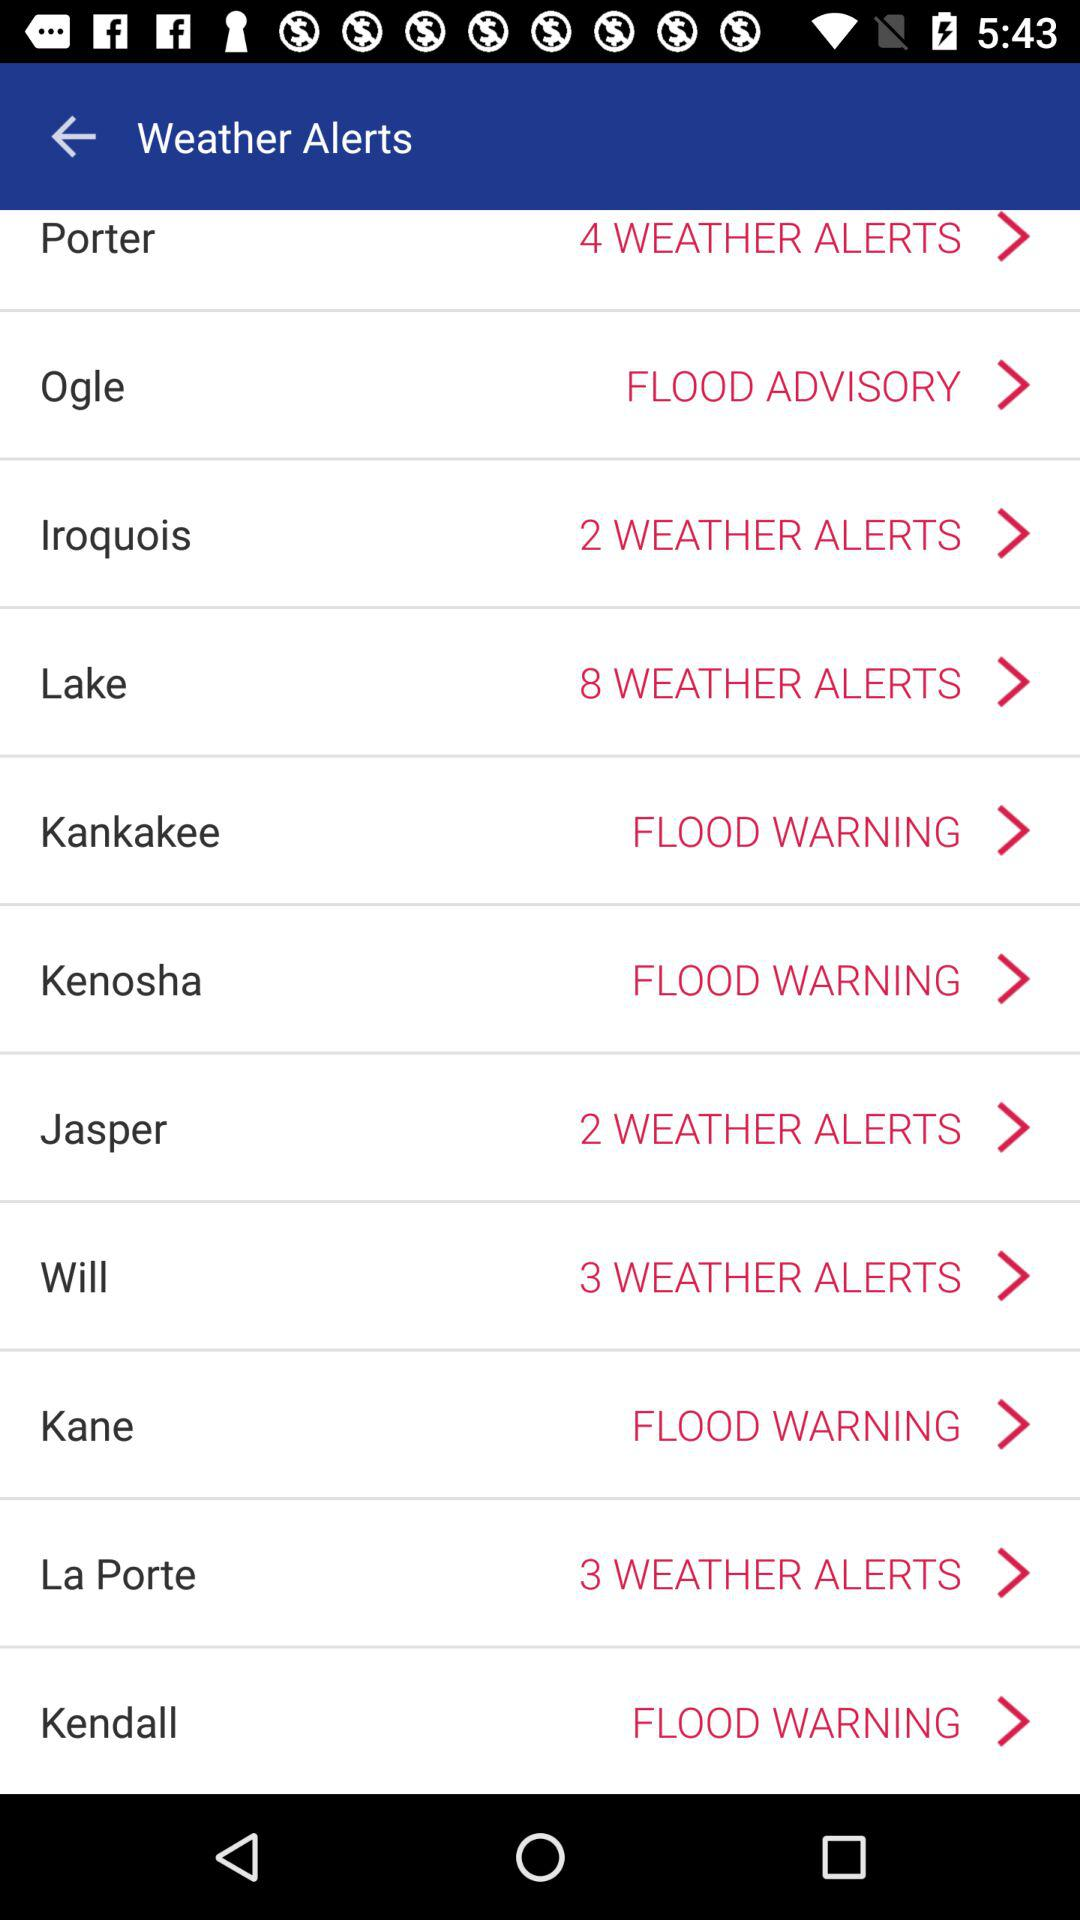What is the weather alert for Kane? The weather alert for Kane is "FLOOD WARNING". 